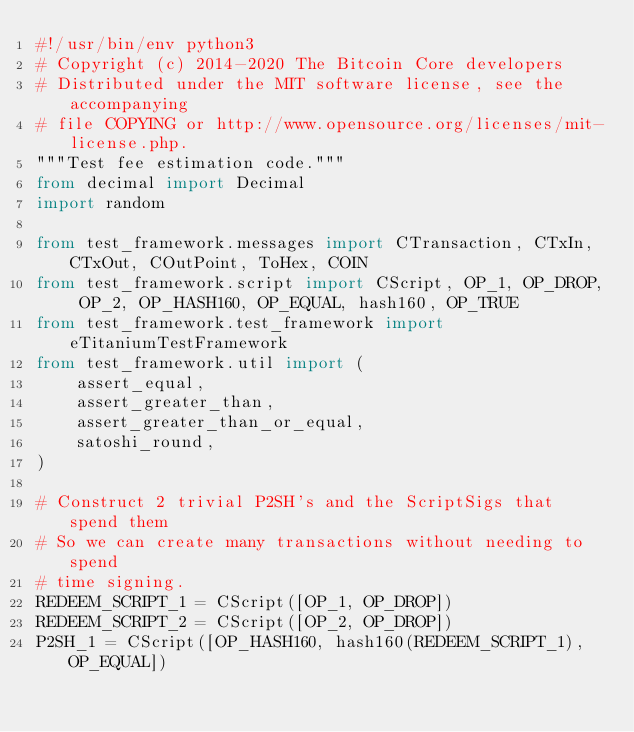Convert code to text. <code><loc_0><loc_0><loc_500><loc_500><_Python_>#!/usr/bin/env python3
# Copyright (c) 2014-2020 The Bitcoin Core developers
# Distributed under the MIT software license, see the accompanying
# file COPYING or http://www.opensource.org/licenses/mit-license.php.
"""Test fee estimation code."""
from decimal import Decimal
import random

from test_framework.messages import CTransaction, CTxIn, CTxOut, COutPoint, ToHex, COIN
from test_framework.script import CScript, OP_1, OP_DROP, OP_2, OP_HASH160, OP_EQUAL, hash160, OP_TRUE
from test_framework.test_framework import eTitaniumTestFramework
from test_framework.util import (
    assert_equal,
    assert_greater_than,
    assert_greater_than_or_equal,
    satoshi_round,
)

# Construct 2 trivial P2SH's and the ScriptSigs that spend them
# So we can create many transactions without needing to spend
# time signing.
REDEEM_SCRIPT_1 = CScript([OP_1, OP_DROP])
REDEEM_SCRIPT_2 = CScript([OP_2, OP_DROP])
P2SH_1 = CScript([OP_HASH160, hash160(REDEEM_SCRIPT_1), OP_EQUAL])</code> 